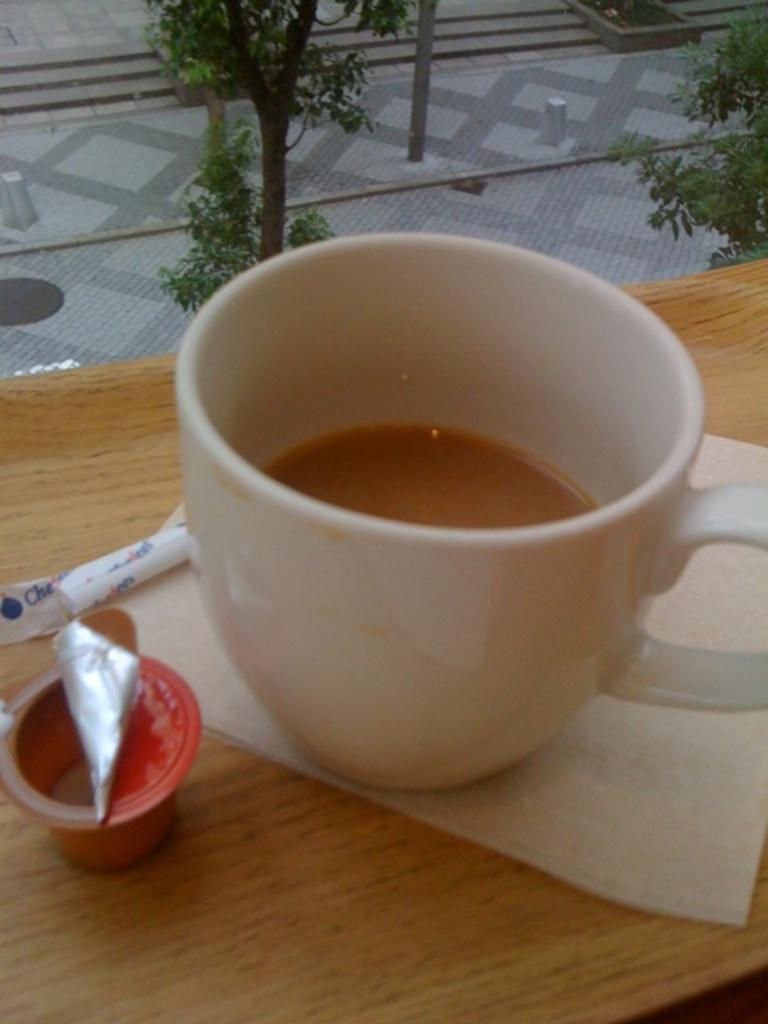What is contained in the cup that is visible in the image? There is a cup of liquid in the image. What type of material is used for the tissue paper in the image? The tissue paper in the image is made of paper. What is the surface on which other items are placed in the image? There are other things placed on a wooden board in the image. What type of natural environment is visible in the image? Trees are visible in the image, suggesting a natural setting. What is the general layout of the image? The image appears to depict a pathway. What is the taste of the hall in the image? There is no hall present in the image, and therefore no taste can be associated with it. Can you describe the stream visible in the image? There is no stream visible in the image; it features a cup of liquid, tissue paper, other items on a wooden board, trees, and a pathway. 